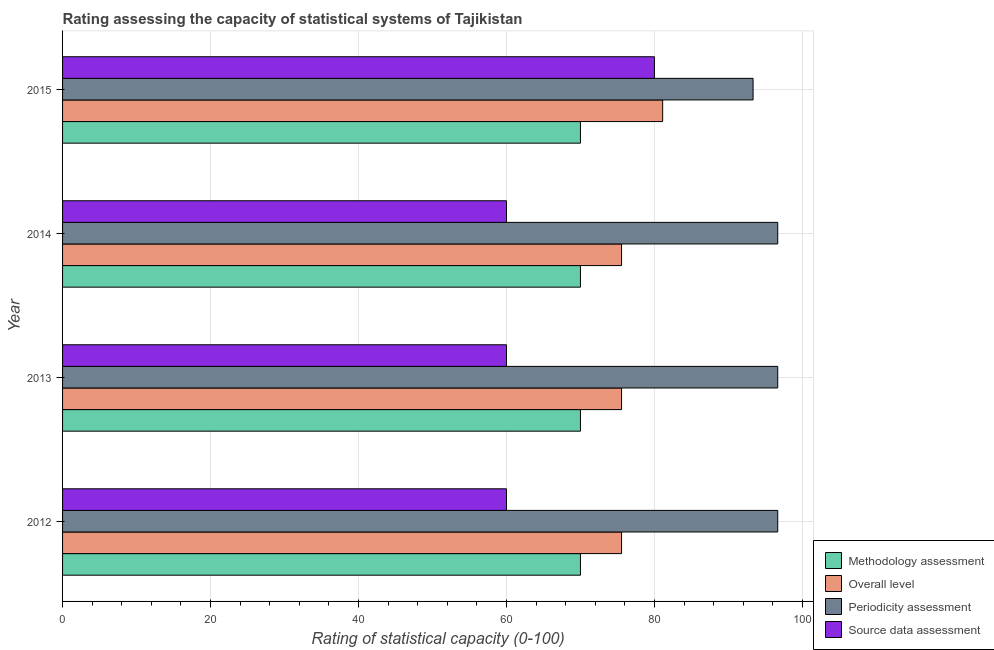How many different coloured bars are there?
Make the answer very short. 4. How many groups of bars are there?
Your answer should be compact. 4. Are the number of bars per tick equal to the number of legend labels?
Your answer should be compact. Yes. Are the number of bars on each tick of the Y-axis equal?
Your response must be concise. Yes. What is the methodology assessment rating in 2015?
Ensure brevity in your answer.  70. Across all years, what is the maximum overall level rating?
Your answer should be very brief. 81.11. Across all years, what is the minimum methodology assessment rating?
Give a very brief answer. 70. In which year was the source data assessment rating maximum?
Offer a terse response. 2015. In which year was the periodicity assessment rating minimum?
Your answer should be compact. 2015. What is the total source data assessment rating in the graph?
Your answer should be compact. 260. What is the difference between the methodology assessment rating in 2013 and the source data assessment rating in 2014?
Make the answer very short. 10. What is the average periodicity assessment rating per year?
Your answer should be compact. 95.83. In the year 2012, what is the difference between the source data assessment rating and overall level rating?
Your answer should be compact. -15.56. What is the ratio of the periodicity assessment rating in 2013 to that in 2014?
Make the answer very short. 1. Is the difference between the source data assessment rating in 2014 and 2015 greater than the difference between the methodology assessment rating in 2014 and 2015?
Your answer should be very brief. No. What is the difference between the highest and the second highest source data assessment rating?
Your answer should be very brief. 20. What is the difference between the highest and the lowest periodicity assessment rating?
Give a very brief answer. 3.33. Is it the case that in every year, the sum of the methodology assessment rating and source data assessment rating is greater than the sum of overall level rating and periodicity assessment rating?
Provide a short and direct response. No. What does the 2nd bar from the top in 2015 represents?
Your response must be concise. Periodicity assessment. What does the 1st bar from the bottom in 2013 represents?
Provide a short and direct response. Methodology assessment. Are all the bars in the graph horizontal?
Offer a very short reply. Yes. Does the graph contain grids?
Offer a terse response. Yes. Where does the legend appear in the graph?
Give a very brief answer. Bottom right. How many legend labels are there?
Offer a terse response. 4. How are the legend labels stacked?
Your answer should be compact. Vertical. What is the title of the graph?
Your response must be concise. Rating assessing the capacity of statistical systems of Tajikistan. Does "UNTA" appear as one of the legend labels in the graph?
Your answer should be compact. No. What is the label or title of the X-axis?
Provide a succinct answer. Rating of statistical capacity (0-100). What is the Rating of statistical capacity (0-100) of Methodology assessment in 2012?
Give a very brief answer. 70. What is the Rating of statistical capacity (0-100) in Overall level in 2012?
Your answer should be compact. 75.56. What is the Rating of statistical capacity (0-100) of Periodicity assessment in 2012?
Keep it short and to the point. 96.67. What is the Rating of statistical capacity (0-100) of Source data assessment in 2012?
Keep it short and to the point. 60. What is the Rating of statistical capacity (0-100) in Methodology assessment in 2013?
Make the answer very short. 70. What is the Rating of statistical capacity (0-100) in Overall level in 2013?
Make the answer very short. 75.56. What is the Rating of statistical capacity (0-100) in Periodicity assessment in 2013?
Provide a short and direct response. 96.67. What is the Rating of statistical capacity (0-100) of Overall level in 2014?
Make the answer very short. 75.56. What is the Rating of statistical capacity (0-100) in Periodicity assessment in 2014?
Make the answer very short. 96.67. What is the Rating of statistical capacity (0-100) in Source data assessment in 2014?
Provide a short and direct response. 60. What is the Rating of statistical capacity (0-100) in Overall level in 2015?
Offer a terse response. 81.11. What is the Rating of statistical capacity (0-100) in Periodicity assessment in 2015?
Offer a terse response. 93.33. Across all years, what is the maximum Rating of statistical capacity (0-100) in Overall level?
Your answer should be compact. 81.11. Across all years, what is the maximum Rating of statistical capacity (0-100) in Periodicity assessment?
Your answer should be very brief. 96.67. Across all years, what is the minimum Rating of statistical capacity (0-100) of Methodology assessment?
Keep it short and to the point. 70. Across all years, what is the minimum Rating of statistical capacity (0-100) in Overall level?
Provide a succinct answer. 75.56. Across all years, what is the minimum Rating of statistical capacity (0-100) of Periodicity assessment?
Offer a terse response. 93.33. Across all years, what is the minimum Rating of statistical capacity (0-100) in Source data assessment?
Your answer should be compact. 60. What is the total Rating of statistical capacity (0-100) in Methodology assessment in the graph?
Offer a terse response. 280. What is the total Rating of statistical capacity (0-100) in Overall level in the graph?
Offer a terse response. 307.78. What is the total Rating of statistical capacity (0-100) of Periodicity assessment in the graph?
Your answer should be compact. 383.33. What is the total Rating of statistical capacity (0-100) in Source data assessment in the graph?
Your answer should be very brief. 260. What is the difference between the Rating of statistical capacity (0-100) of Methodology assessment in 2012 and that in 2013?
Offer a terse response. 0. What is the difference between the Rating of statistical capacity (0-100) of Overall level in 2012 and that in 2013?
Provide a short and direct response. 0. What is the difference between the Rating of statistical capacity (0-100) of Periodicity assessment in 2012 and that in 2013?
Offer a terse response. 0. What is the difference between the Rating of statistical capacity (0-100) in Source data assessment in 2012 and that in 2013?
Give a very brief answer. 0. What is the difference between the Rating of statistical capacity (0-100) of Methodology assessment in 2012 and that in 2014?
Your response must be concise. 0. What is the difference between the Rating of statistical capacity (0-100) in Overall level in 2012 and that in 2014?
Provide a short and direct response. 0. What is the difference between the Rating of statistical capacity (0-100) in Methodology assessment in 2012 and that in 2015?
Offer a very short reply. 0. What is the difference between the Rating of statistical capacity (0-100) in Overall level in 2012 and that in 2015?
Offer a terse response. -5.56. What is the difference between the Rating of statistical capacity (0-100) in Source data assessment in 2012 and that in 2015?
Ensure brevity in your answer.  -20. What is the difference between the Rating of statistical capacity (0-100) in Source data assessment in 2013 and that in 2014?
Give a very brief answer. 0. What is the difference between the Rating of statistical capacity (0-100) in Overall level in 2013 and that in 2015?
Provide a succinct answer. -5.56. What is the difference between the Rating of statistical capacity (0-100) in Overall level in 2014 and that in 2015?
Ensure brevity in your answer.  -5.56. What is the difference between the Rating of statistical capacity (0-100) in Source data assessment in 2014 and that in 2015?
Offer a terse response. -20. What is the difference between the Rating of statistical capacity (0-100) of Methodology assessment in 2012 and the Rating of statistical capacity (0-100) of Overall level in 2013?
Provide a succinct answer. -5.56. What is the difference between the Rating of statistical capacity (0-100) of Methodology assessment in 2012 and the Rating of statistical capacity (0-100) of Periodicity assessment in 2013?
Offer a terse response. -26.67. What is the difference between the Rating of statistical capacity (0-100) in Overall level in 2012 and the Rating of statistical capacity (0-100) in Periodicity assessment in 2013?
Give a very brief answer. -21.11. What is the difference between the Rating of statistical capacity (0-100) of Overall level in 2012 and the Rating of statistical capacity (0-100) of Source data assessment in 2013?
Your answer should be very brief. 15.56. What is the difference between the Rating of statistical capacity (0-100) of Periodicity assessment in 2012 and the Rating of statistical capacity (0-100) of Source data assessment in 2013?
Ensure brevity in your answer.  36.67. What is the difference between the Rating of statistical capacity (0-100) of Methodology assessment in 2012 and the Rating of statistical capacity (0-100) of Overall level in 2014?
Offer a very short reply. -5.56. What is the difference between the Rating of statistical capacity (0-100) in Methodology assessment in 2012 and the Rating of statistical capacity (0-100) in Periodicity assessment in 2014?
Offer a terse response. -26.67. What is the difference between the Rating of statistical capacity (0-100) of Overall level in 2012 and the Rating of statistical capacity (0-100) of Periodicity assessment in 2014?
Your response must be concise. -21.11. What is the difference between the Rating of statistical capacity (0-100) of Overall level in 2012 and the Rating of statistical capacity (0-100) of Source data assessment in 2014?
Give a very brief answer. 15.56. What is the difference between the Rating of statistical capacity (0-100) of Periodicity assessment in 2012 and the Rating of statistical capacity (0-100) of Source data assessment in 2014?
Offer a very short reply. 36.67. What is the difference between the Rating of statistical capacity (0-100) in Methodology assessment in 2012 and the Rating of statistical capacity (0-100) in Overall level in 2015?
Give a very brief answer. -11.11. What is the difference between the Rating of statistical capacity (0-100) of Methodology assessment in 2012 and the Rating of statistical capacity (0-100) of Periodicity assessment in 2015?
Make the answer very short. -23.33. What is the difference between the Rating of statistical capacity (0-100) in Overall level in 2012 and the Rating of statistical capacity (0-100) in Periodicity assessment in 2015?
Your answer should be compact. -17.78. What is the difference between the Rating of statistical capacity (0-100) in Overall level in 2012 and the Rating of statistical capacity (0-100) in Source data assessment in 2015?
Your answer should be very brief. -4.44. What is the difference between the Rating of statistical capacity (0-100) in Periodicity assessment in 2012 and the Rating of statistical capacity (0-100) in Source data assessment in 2015?
Keep it short and to the point. 16.67. What is the difference between the Rating of statistical capacity (0-100) in Methodology assessment in 2013 and the Rating of statistical capacity (0-100) in Overall level in 2014?
Ensure brevity in your answer.  -5.56. What is the difference between the Rating of statistical capacity (0-100) of Methodology assessment in 2013 and the Rating of statistical capacity (0-100) of Periodicity assessment in 2014?
Your response must be concise. -26.67. What is the difference between the Rating of statistical capacity (0-100) in Overall level in 2013 and the Rating of statistical capacity (0-100) in Periodicity assessment in 2014?
Offer a very short reply. -21.11. What is the difference between the Rating of statistical capacity (0-100) in Overall level in 2013 and the Rating of statistical capacity (0-100) in Source data assessment in 2014?
Offer a very short reply. 15.56. What is the difference between the Rating of statistical capacity (0-100) in Periodicity assessment in 2013 and the Rating of statistical capacity (0-100) in Source data assessment in 2014?
Make the answer very short. 36.67. What is the difference between the Rating of statistical capacity (0-100) of Methodology assessment in 2013 and the Rating of statistical capacity (0-100) of Overall level in 2015?
Ensure brevity in your answer.  -11.11. What is the difference between the Rating of statistical capacity (0-100) of Methodology assessment in 2013 and the Rating of statistical capacity (0-100) of Periodicity assessment in 2015?
Offer a terse response. -23.33. What is the difference between the Rating of statistical capacity (0-100) in Overall level in 2013 and the Rating of statistical capacity (0-100) in Periodicity assessment in 2015?
Provide a short and direct response. -17.78. What is the difference between the Rating of statistical capacity (0-100) in Overall level in 2013 and the Rating of statistical capacity (0-100) in Source data assessment in 2015?
Make the answer very short. -4.44. What is the difference between the Rating of statistical capacity (0-100) in Periodicity assessment in 2013 and the Rating of statistical capacity (0-100) in Source data assessment in 2015?
Your response must be concise. 16.67. What is the difference between the Rating of statistical capacity (0-100) in Methodology assessment in 2014 and the Rating of statistical capacity (0-100) in Overall level in 2015?
Keep it short and to the point. -11.11. What is the difference between the Rating of statistical capacity (0-100) in Methodology assessment in 2014 and the Rating of statistical capacity (0-100) in Periodicity assessment in 2015?
Provide a succinct answer. -23.33. What is the difference between the Rating of statistical capacity (0-100) of Overall level in 2014 and the Rating of statistical capacity (0-100) of Periodicity assessment in 2015?
Give a very brief answer. -17.78. What is the difference between the Rating of statistical capacity (0-100) of Overall level in 2014 and the Rating of statistical capacity (0-100) of Source data assessment in 2015?
Make the answer very short. -4.44. What is the difference between the Rating of statistical capacity (0-100) of Periodicity assessment in 2014 and the Rating of statistical capacity (0-100) of Source data assessment in 2015?
Your answer should be compact. 16.67. What is the average Rating of statistical capacity (0-100) of Overall level per year?
Provide a succinct answer. 76.94. What is the average Rating of statistical capacity (0-100) of Periodicity assessment per year?
Your answer should be compact. 95.83. What is the average Rating of statistical capacity (0-100) of Source data assessment per year?
Offer a very short reply. 65. In the year 2012, what is the difference between the Rating of statistical capacity (0-100) of Methodology assessment and Rating of statistical capacity (0-100) of Overall level?
Provide a short and direct response. -5.56. In the year 2012, what is the difference between the Rating of statistical capacity (0-100) in Methodology assessment and Rating of statistical capacity (0-100) in Periodicity assessment?
Provide a short and direct response. -26.67. In the year 2012, what is the difference between the Rating of statistical capacity (0-100) in Overall level and Rating of statistical capacity (0-100) in Periodicity assessment?
Your answer should be very brief. -21.11. In the year 2012, what is the difference between the Rating of statistical capacity (0-100) in Overall level and Rating of statistical capacity (0-100) in Source data assessment?
Make the answer very short. 15.56. In the year 2012, what is the difference between the Rating of statistical capacity (0-100) of Periodicity assessment and Rating of statistical capacity (0-100) of Source data assessment?
Your answer should be very brief. 36.67. In the year 2013, what is the difference between the Rating of statistical capacity (0-100) in Methodology assessment and Rating of statistical capacity (0-100) in Overall level?
Give a very brief answer. -5.56. In the year 2013, what is the difference between the Rating of statistical capacity (0-100) of Methodology assessment and Rating of statistical capacity (0-100) of Periodicity assessment?
Your answer should be very brief. -26.67. In the year 2013, what is the difference between the Rating of statistical capacity (0-100) of Methodology assessment and Rating of statistical capacity (0-100) of Source data assessment?
Ensure brevity in your answer.  10. In the year 2013, what is the difference between the Rating of statistical capacity (0-100) of Overall level and Rating of statistical capacity (0-100) of Periodicity assessment?
Your answer should be compact. -21.11. In the year 2013, what is the difference between the Rating of statistical capacity (0-100) in Overall level and Rating of statistical capacity (0-100) in Source data assessment?
Your response must be concise. 15.56. In the year 2013, what is the difference between the Rating of statistical capacity (0-100) of Periodicity assessment and Rating of statistical capacity (0-100) of Source data assessment?
Your answer should be compact. 36.67. In the year 2014, what is the difference between the Rating of statistical capacity (0-100) of Methodology assessment and Rating of statistical capacity (0-100) of Overall level?
Ensure brevity in your answer.  -5.56. In the year 2014, what is the difference between the Rating of statistical capacity (0-100) of Methodology assessment and Rating of statistical capacity (0-100) of Periodicity assessment?
Ensure brevity in your answer.  -26.67. In the year 2014, what is the difference between the Rating of statistical capacity (0-100) of Methodology assessment and Rating of statistical capacity (0-100) of Source data assessment?
Make the answer very short. 10. In the year 2014, what is the difference between the Rating of statistical capacity (0-100) in Overall level and Rating of statistical capacity (0-100) in Periodicity assessment?
Keep it short and to the point. -21.11. In the year 2014, what is the difference between the Rating of statistical capacity (0-100) in Overall level and Rating of statistical capacity (0-100) in Source data assessment?
Provide a short and direct response. 15.56. In the year 2014, what is the difference between the Rating of statistical capacity (0-100) of Periodicity assessment and Rating of statistical capacity (0-100) of Source data assessment?
Provide a short and direct response. 36.67. In the year 2015, what is the difference between the Rating of statistical capacity (0-100) of Methodology assessment and Rating of statistical capacity (0-100) of Overall level?
Offer a very short reply. -11.11. In the year 2015, what is the difference between the Rating of statistical capacity (0-100) of Methodology assessment and Rating of statistical capacity (0-100) of Periodicity assessment?
Make the answer very short. -23.33. In the year 2015, what is the difference between the Rating of statistical capacity (0-100) of Methodology assessment and Rating of statistical capacity (0-100) of Source data assessment?
Give a very brief answer. -10. In the year 2015, what is the difference between the Rating of statistical capacity (0-100) of Overall level and Rating of statistical capacity (0-100) of Periodicity assessment?
Keep it short and to the point. -12.22. In the year 2015, what is the difference between the Rating of statistical capacity (0-100) of Periodicity assessment and Rating of statistical capacity (0-100) of Source data assessment?
Make the answer very short. 13.33. What is the ratio of the Rating of statistical capacity (0-100) of Overall level in 2012 to that in 2014?
Ensure brevity in your answer.  1. What is the ratio of the Rating of statistical capacity (0-100) of Periodicity assessment in 2012 to that in 2014?
Provide a succinct answer. 1. What is the ratio of the Rating of statistical capacity (0-100) of Source data assessment in 2012 to that in 2014?
Provide a succinct answer. 1. What is the ratio of the Rating of statistical capacity (0-100) in Overall level in 2012 to that in 2015?
Your answer should be very brief. 0.93. What is the ratio of the Rating of statistical capacity (0-100) in Periodicity assessment in 2012 to that in 2015?
Your response must be concise. 1.04. What is the ratio of the Rating of statistical capacity (0-100) in Periodicity assessment in 2013 to that in 2014?
Your answer should be very brief. 1. What is the ratio of the Rating of statistical capacity (0-100) in Source data assessment in 2013 to that in 2014?
Offer a very short reply. 1. What is the ratio of the Rating of statistical capacity (0-100) of Overall level in 2013 to that in 2015?
Offer a very short reply. 0.93. What is the ratio of the Rating of statistical capacity (0-100) in Periodicity assessment in 2013 to that in 2015?
Ensure brevity in your answer.  1.04. What is the ratio of the Rating of statistical capacity (0-100) of Source data assessment in 2013 to that in 2015?
Offer a very short reply. 0.75. What is the ratio of the Rating of statistical capacity (0-100) in Methodology assessment in 2014 to that in 2015?
Provide a short and direct response. 1. What is the ratio of the Rating of statistical capacity (0-100) of Overall level in 2014 to that in 2015?
Make the answer very short. 0.93. What is the ratio of the Rating of statistical capacity (0-100) of Periodicity assessment in 2014 to that in 2015?
Give a very brief answer. 1.04. What is the difference between the highest and the second highest Rating of statistical capacity (0-100) in Methodology assessment?
Your answer should be compact. 0. What is the difference between the highest and the second highest Rating of statistical capacity (0-100) in Overall level?
Make the answer very short. 5.56. What is the difference between the highest and the second highest Rating of statistical capacity (0-100) in Periodicity assessment?
Offer a very short reply. 0. What is the difference between the highest and the lowest Rating of statistical capacity (0-100) in Overall level?
Your response must be concise. 5.56. What is the difference between the highest and the lowest Rating of statistical capacity (0-100) in Periodicity assessment?
Offer a very short reply. 3.33. What is the difference between the highest and the lowest Rating of statistical capacity (0-100) in Source data assessment?
Provide a succinct answer. 20. 